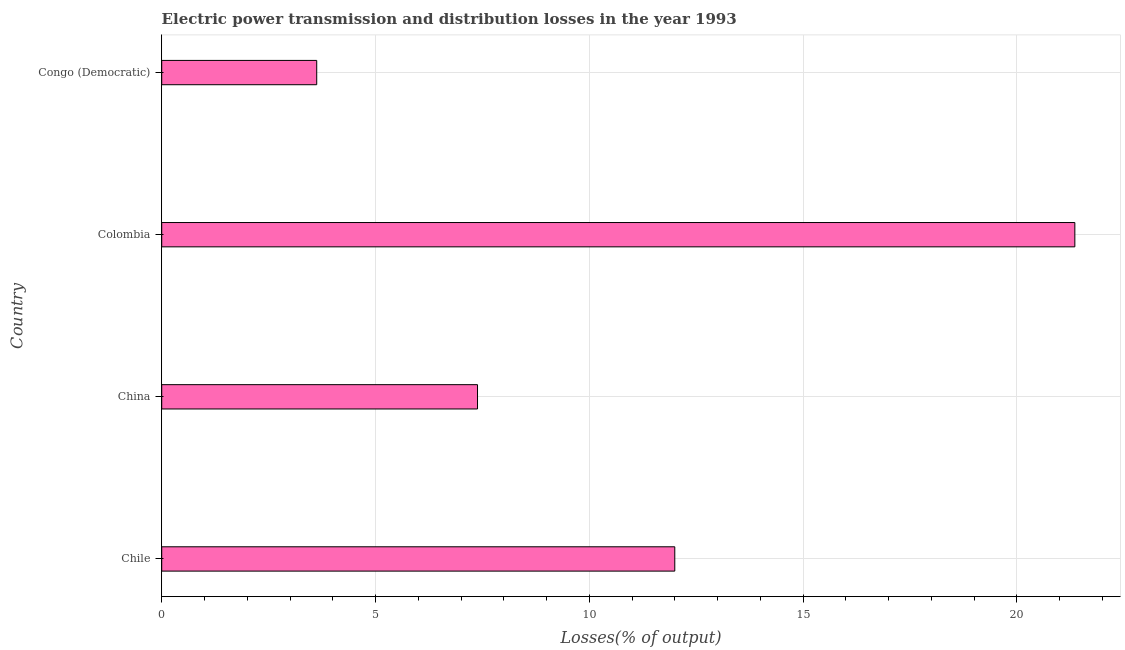Does the graph contain grids?
Your answer should be very brief. Yes. What is the title of the graph?
Your answer should be compact. Electric power transmission and distribution losses in the year 1993. What is the label or title of the X-axis?
Make the answer very short. Losses(% of output). What is the label or title of the Y-axis?
Provide a succinct answer. Country. What is the electric power transmission and distribution losses in Congo (Democratic)?
Give a very brief answer. 3.62. Across all countries, what is the maximum electric power transmission and distribution losses?
Your answer should be compact. 21.35. Across all countries, what is the minimum electric power transmission and distribution losses?
Make the answer very short. 3.62. In which country was the electric power transmission and distribution losses maximum?
Keep it short and to the point. Colombia. In which country was the electric power transmission and distribution losses minimum?
Offer a terse response. Congo (Democratic). What is the sum of the electric power transmission and distribution losses?
Provide a short and direct response. 44.36. What is the difference between the electric power transmission and distribution losses in Colombia and Congo (Democratic)?
Offer a very short reply. 17.73. What is the average electric power transmission and distribution losses per country?
Make the answer very short. 11.09. What is the median electric power transmission and distribution losses?
Keep it short and to the point. 9.69. What is the ratio of the electric power transmission and distribution losses in Colombia to that in Congo (Democratic)?
Make the answer very short. 5.89. Is the electric power transmission and distribution losses in Chile less than that in Colombia?
Your answer should be compact. Yes. What is the difference between the highest and the second highest electric power transmission and distribution losses?
Give a very brief answer. 9.36. What is the difference between the highest and the lowest electric power transmission and distribution losses?
Your answer should be very brief. 17.73. In how many countries, is the electric power transmission and distribution losses greater than the average electric power transmission and distribution losses taken over all countries?
Your response must be concise. 2. How many bars are there?
Offer a terse response. 4. Are all the bars in the graph horizontal?
Provide a short and direct response. Yes. How many countries are there in the graph?
Offer a terse response. 4. Are the values on the major ticks of X-axis written in scientific E-notation?
Make the answer very short. No. What is the Losses(% of output) of Chile?
Your answer should be compact. 12. What is the Losses(% of output) in China?
Offer a terse response. 7.39. What is the Losses(% of output) of Colombia?
Your response must be concise. 21.35. What is the Losses(% of output) of Congo (Democratic)?
Your answer should be compact. 3.62. What is the difference between the Losses(% of output) in Chile and China?
Ensure brevity in your answer.  4.61. What is the difference between the Losses(% of output) in Chile and Colombia?
Ensure brevity in your answer.  -9.36. What is the difference between the Losses(% of output) in Chile and Congo (Democratic)?
Ensure brevity in your answer.  8.37. What is the difference between the Losses(% of output) in China and Colombia?
Your answer should be compact. -13.97. What is the difference between the Losses(% of output) in China and Congo (Democratic)?
Your answer should be compact. 3.76. What is the difference between the Losses(% of output) in Colombia and Congo (Democratic)?
Ensure brevity in your answer.  17.73. What is the ratio of the Losses(% of output) in Chile to that in China?
Make the answer very short. 1.62. What is the ratio of the Losses(% of output) in Chile to that in Colombia?
Keep it short and to the point. 0.56. What is the ratio of the Losses(% of output) in Chile to that in Congo (Democratic)?
Your response must be concise. 3.31. What is the ratio of the Losses(% of output) in China to that in Colombia?
Offer a terse response. 0.35. What is the ratio of the Losses(% of output) in China to that in Congo (Democratic)?
Ensure brevity in your answer.  2.04. What is the ratio of the Losses(% of output) in Colombia to that in Congo (Democratic)?
Your answer should be very brief. 5.89. 